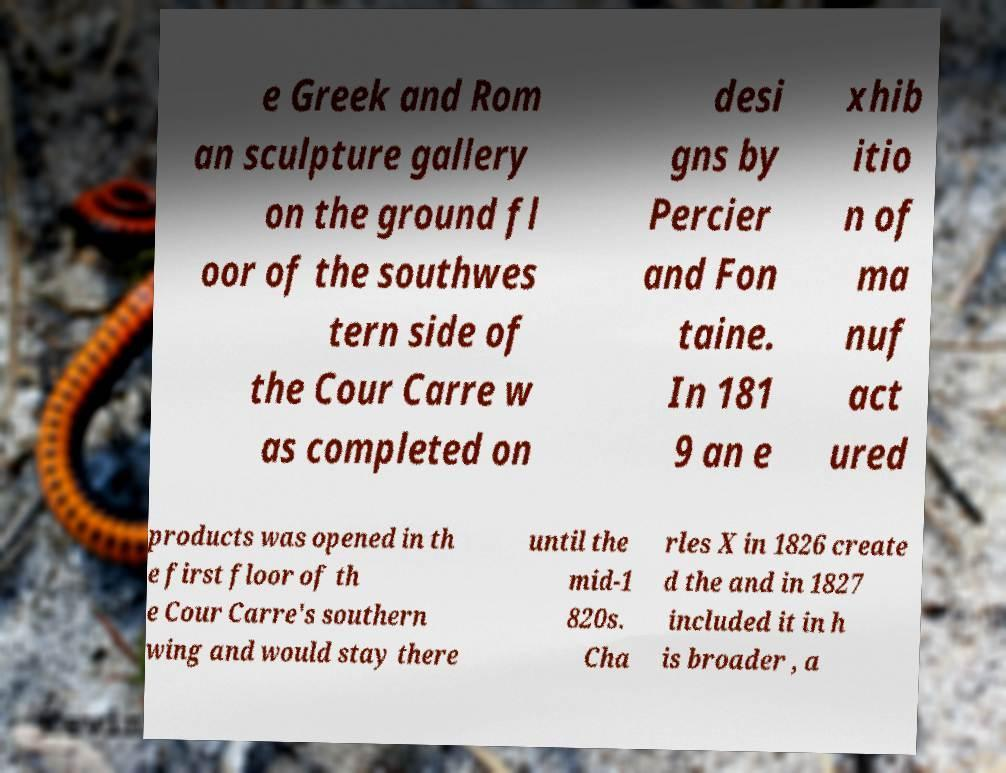Can you accurately transcribe the text from the provided image for me? e Greek and Rom an sculpture gallery on the ground fl oor of the southwes tern side of the Cour Carre w as completed on desi gns by Percier and Fon taine. In 181 9 an e xhib itio n of ma nuf act ured products was opened in th e first floor of th e Cour Carre's southern wing and would stay there until the mid-1 820s. Cha rles X in 1826 create d the and in 1827 included it in h is broader , a 